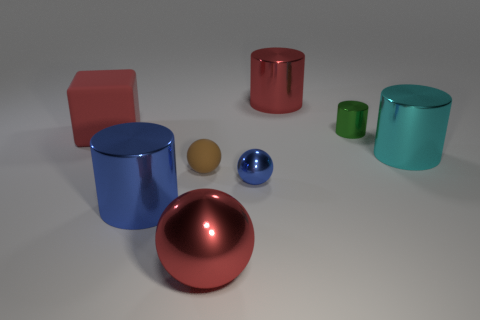Add 2 blue shiny objects. How many objects exist? 10 Subtract all balls. How many objects are left? 5 Add 2 gray balls. How many gray balls exist? 2 Subtract 1 red cylinders. How many objects are left? 7 Subtract all green cylinders. Subtract all big gray metal blocks. How many objects are left? 7 Add 8 tiny brown rubber spheres. How many tiny brown rubber spheres are left? 9 